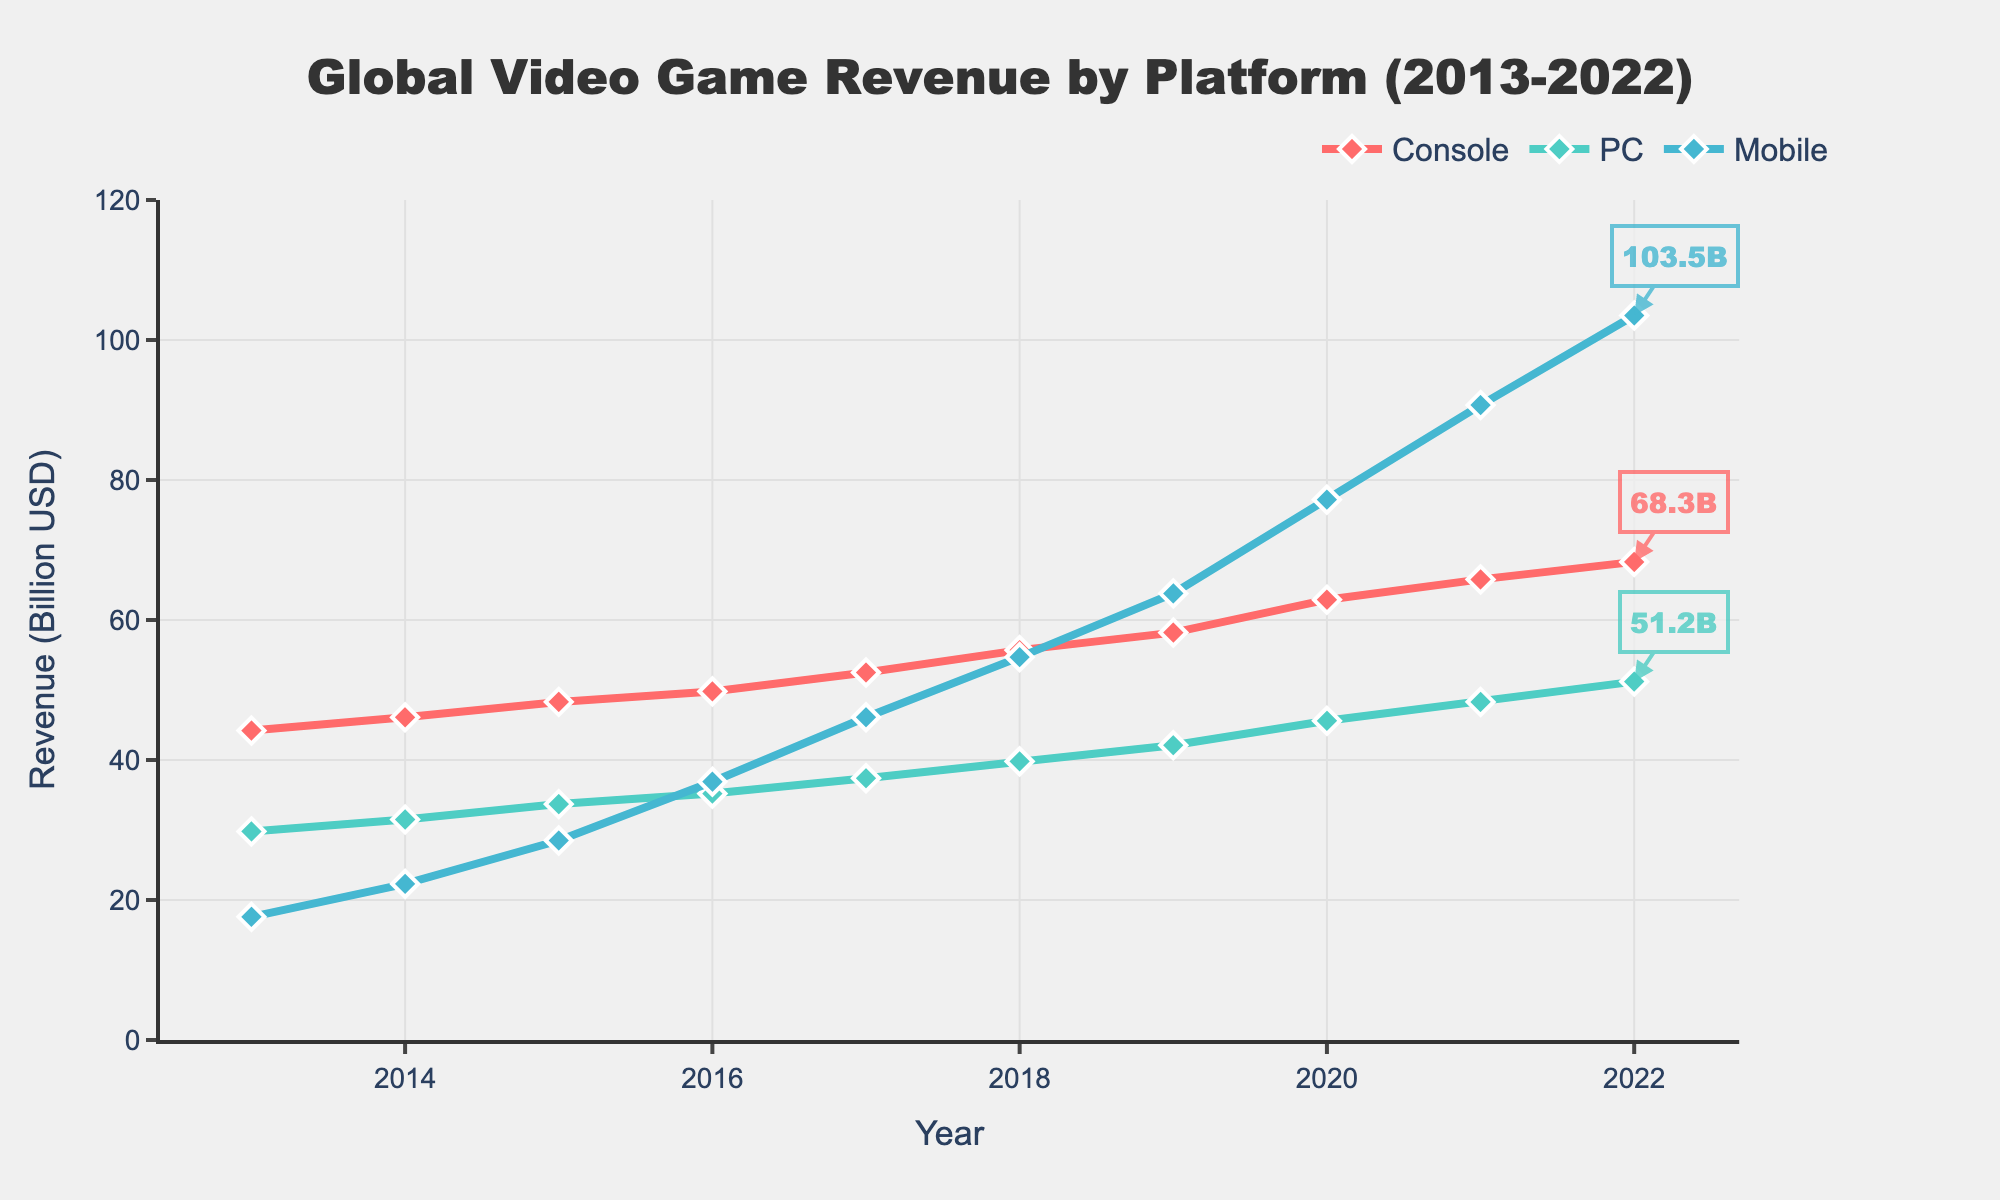Which platform has the highest revenue in 2022? To determine the platform with the highest revenue in 2022, we look for the highest y-value among Console, PC, and Mobile at the year 2022 on the x-axis. The Mobile platform has the highest value at 103.5 billion USD.
Answer: Mobile How much did the revenue for Mobile gaming increase between 2013 and 2022? To calculate the increase, we subtract the 2013 revenue of Mobile (17.6 billion USD) from the 2022 revenue (103.5 billion USD). So, 103.5 - 17.6 = 85.9 billion USD.
Answer: 85.9 billion USD In which year did Console and PC revenues become closest in value? We need to compare the revenues for Console and PC across all years and find the smallest difference. In 2016, Console revenue is 49.8 billion USD and PC revenue is 35.2 billion USD, making the smallest difference of 14.6 billion USD among all years.
Answer: 2016 Which platform showed the most consistent growth over the years 2013 to 2022? We determine consistent growth by looking at systematic increments each year. All platforms show growth, but PC and Console growth are steadier with similar year-to-year increments, compared to the varied and steep growth of Mobile. PC shows the most consistent year-over-year steady increase compared to Console.
Answer: PC What is the total revenue across all platforms in 2020? To find the total revenue in 2020, we add the revenues for Console (62.9 billion USD), PC (45.6 billion USD), and Mobile (77.2 billion USD). So, 62.9 + 45.6 + 77.2 = 185.7 billion USD.
Answer: 185.7 billion USD Between 2016 and 2017, which platform experienced the greatest revenue increase? We calculate the revenue difference for each platform between 2016 and 2017. Console: 52.5 - 49.8 = 2.7 billion USD, PC: 37.4 - 35.2 = 2.2 billion USD, Mobile: 46.1 - 36.9 = 9.2 billion USD. The Mobile platform had the greatest revenue increase of 9.2 billion USD.
Answer: Mobile What is the average yearly revenue for the Console platform between 2013 and 2022? To find the average yearly revenue for the Console platform, sum the revenues from 2013 to 2022 and divide by the number of years (10). The sum is 44.2 + 46.1 + 48.3 + 49.8 + 52.5 + 55.7 + 58.2 + 62.9 + 65.8 + 68.3 = 551.8 billion USD. Dividing by 10 gives an average of 55.18 billion USD.
Answer: 55.18 billion USD How did the growth of Mobile gaming revenue compare to PC gaming revenue between 2014 and 2019? Calculate the growth for both platforms from 2014 to 2019. Mobile: 63.8 - 22.3 = 41.5 billion USD. PC: 42.1 - 31.5 = 10.6 billion USD. Mobile gaming revenue grew by 41.5 billion USD, much higher than PC's growth of 10.6 billion USD.
Answer: Mobile revenue grew more, by 41.5 billion USD What trend can you observe in Mobile gaming revenue across the years? Observation of the line trend of Mobile platform shows that it has been increasing significantly and at a faster rate compared to Console and PC, especially noticeable starting from 2016 to 2022.
Answer: Rapid and continually increasing trend 